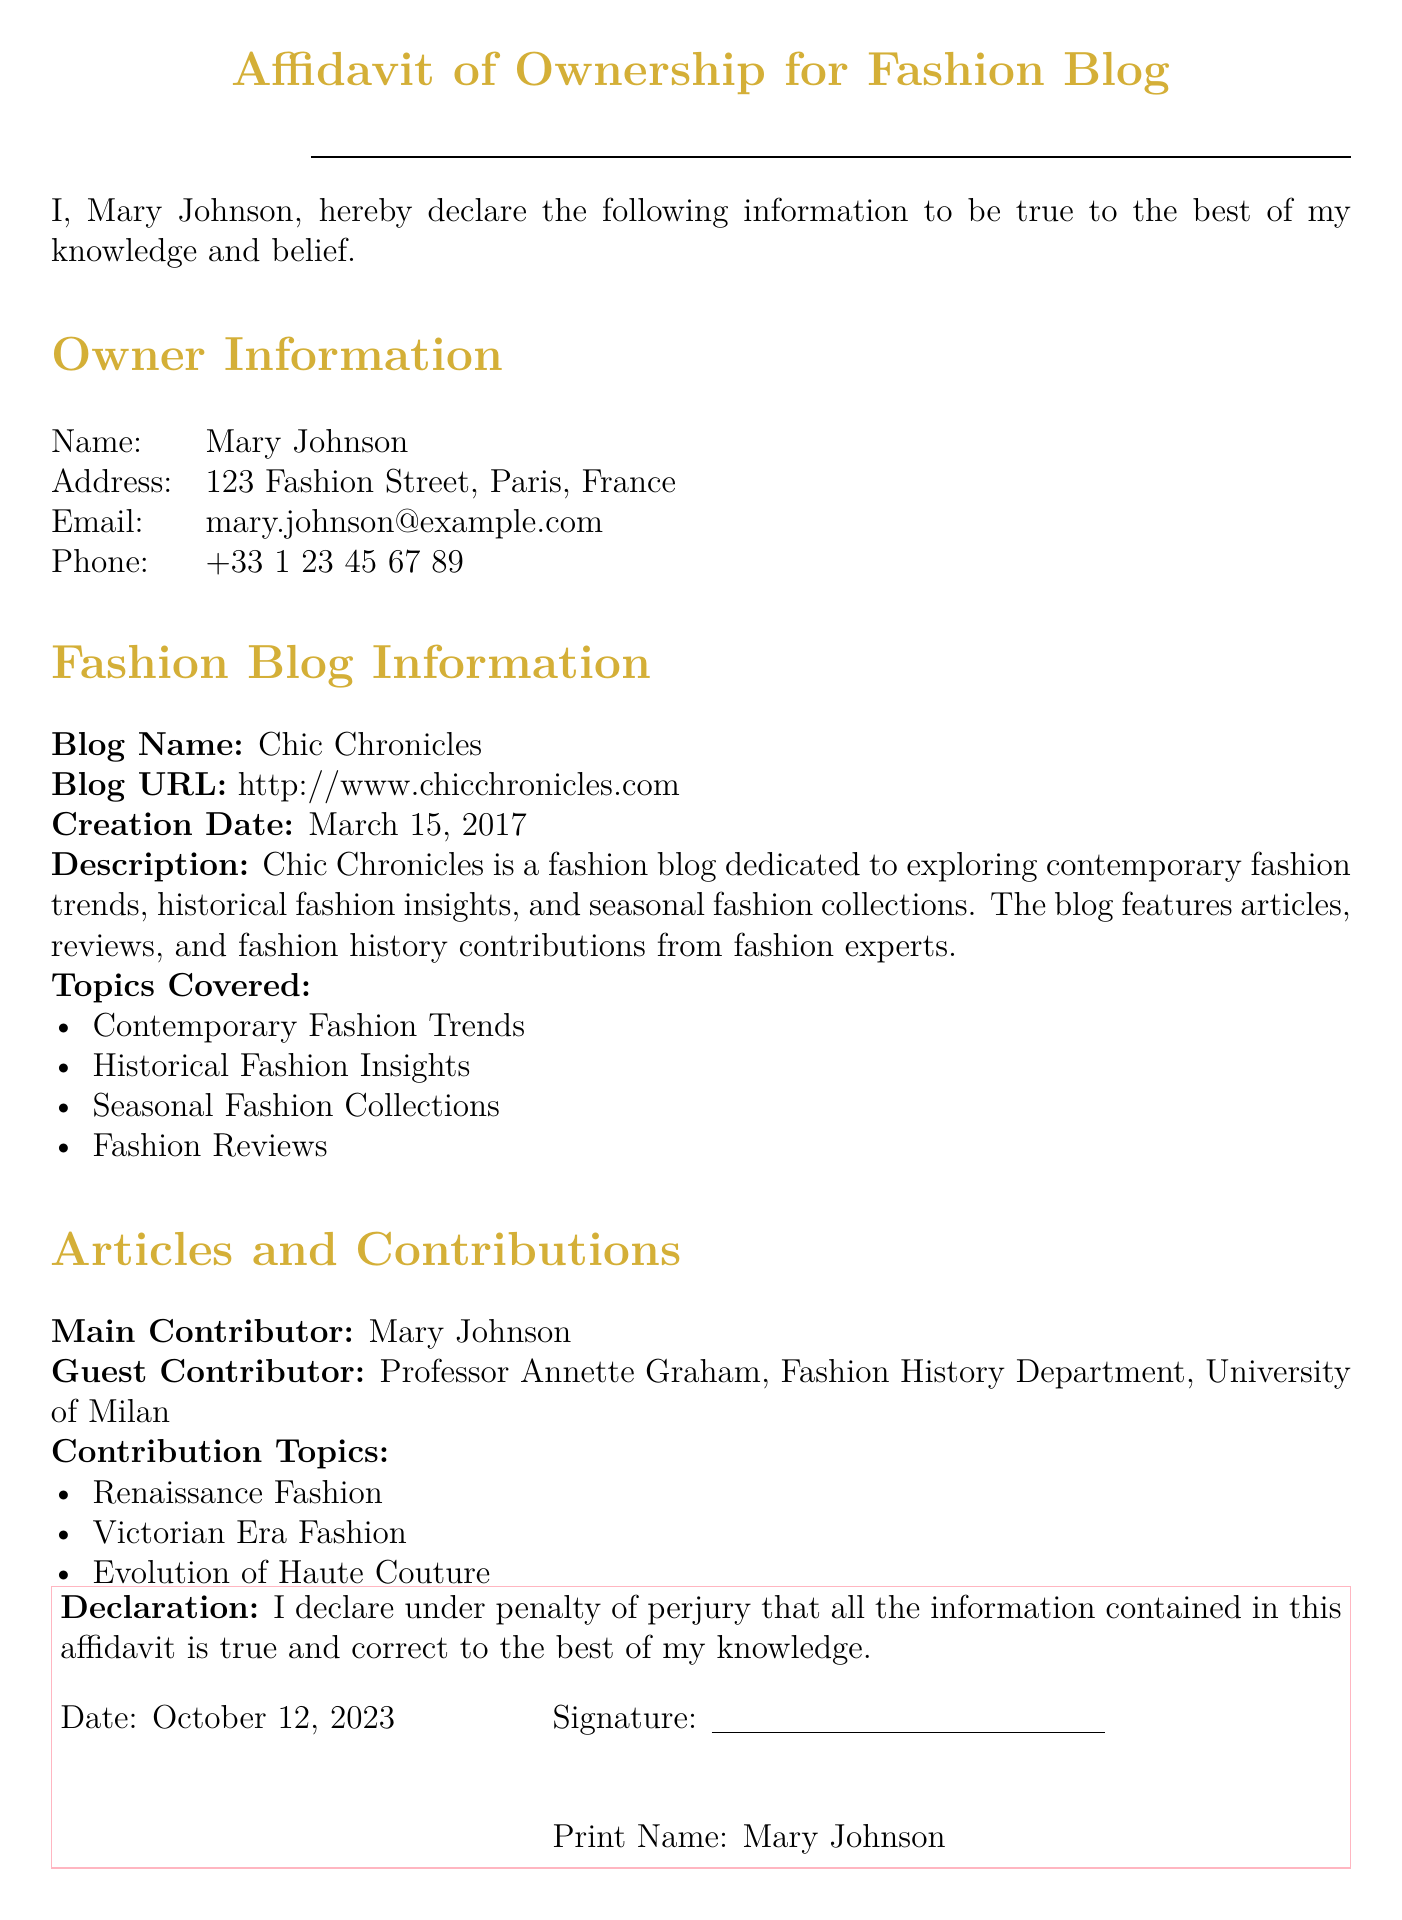What is the owner's name? The owner's name is stated clearly in the document as Mary Johnson.
Answer: Mary Johnson What is the blog's URL? The blog's URL is a specific web address provided in the document.
Answer: http://www.chicchronicles.com When was the blog created? The creation date of the blog is listed in the document.
Answer: March 15, 2017 Who is the main contributor of the blog? The document identifies the main contributor to the blog as Mary Johnson.
Answer: Mary Johnson What topics does the blog cover? The topics listed under the Fashion Blog Information section outline what the blog discusses.
Answer: Contemporary Fashion Trends, Historical Fashion Insights, Seasonal Fashion Collections, Fashion Reviews Who is the guest contributor? The guest contributor's name is noted in the Articles and Contributions section of the document.
Answer: Professor Annette Graham What is the purpose of the declaration? The declaration states the truth and correctness of the information provided in the affidavit.
Answer: True and correct information What is the penalty for providing false information? The document refers to 'penalty of perjury' in the declaration.
Answer: Perjury What is the date of the affidavit? The date is specifically outlined in the declaration section of the document.
Answer: October 12, 2023 